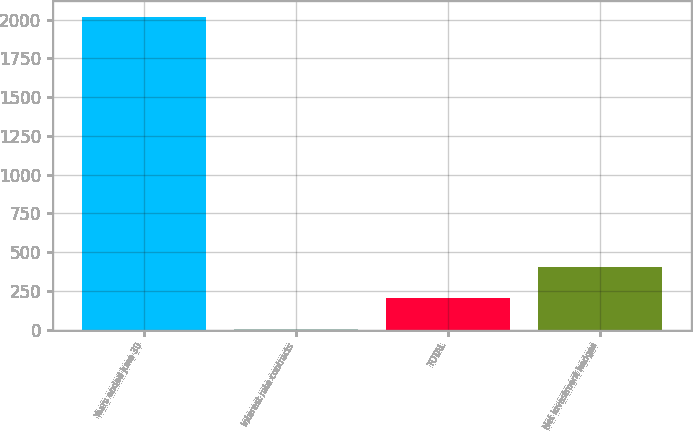Convert chart. <chart><loc_0><loc_0><loc_500><loc_500><bar_chart><fcel>Years ended June 30<fcel>Interest rate contracts<fcel>TOTAL<fcel>Net investment hedges<nl><fcel>2017<fcel>2<fcel>203.5<fcel>405<nl></chart> 